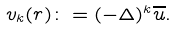<formula> <loc_0><loc_0><loc_500><loc_500>v _ { k } ( r ) \colon = ( - \Delta ) ^ { k } \overline { u } .</formula> 